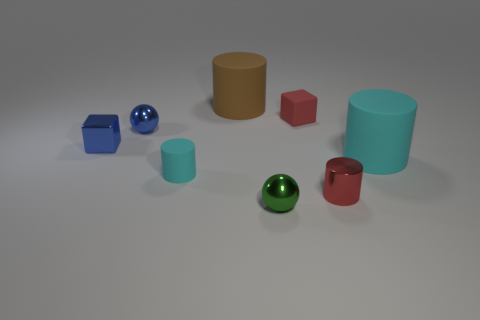Is the number of small cylinders behind the small red metal cylinder greater than the number of gray metallic balls? Yes, there are more small cylinders behind the small red metal cylinder than there are gray metallic balls. Specifically, we can see two small cylinders positioned behind the red one, while there is only one gray metallic ball present in the image. 